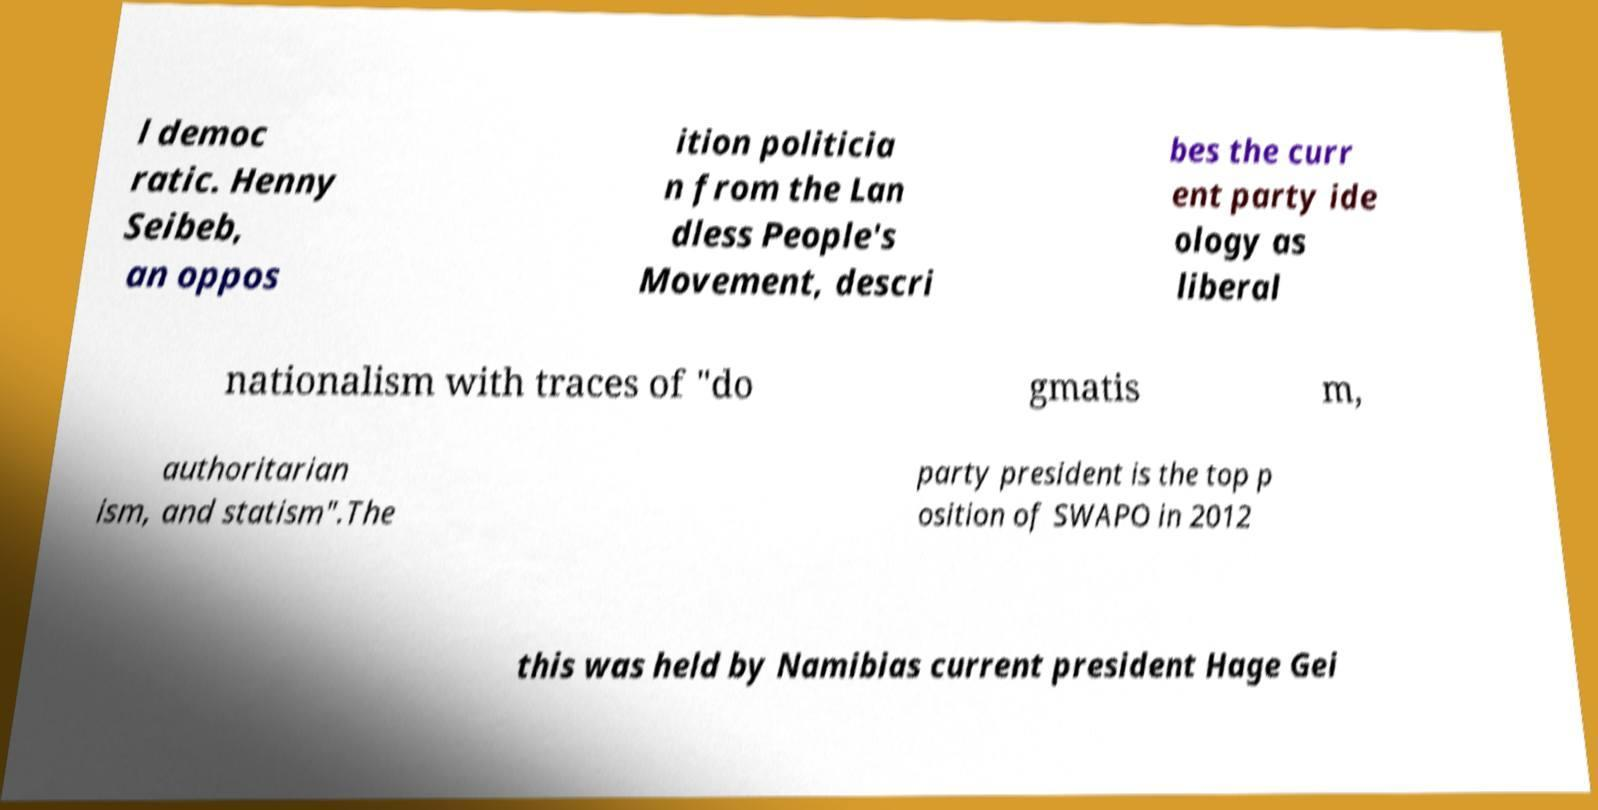Can you accurately transcribe the text from the provided image for me? l democ ratic. Henny Seibeb, an oppos ition politicia n from the Lan dless People's Movement, descri bes the curr ent party ide ology as liberal nationalism with traces of "do gmatis m, authoritarian ism, and statism".The party president is the top p osition of SWAPO in 2012 this was held by Namibias current president Hage Gei 